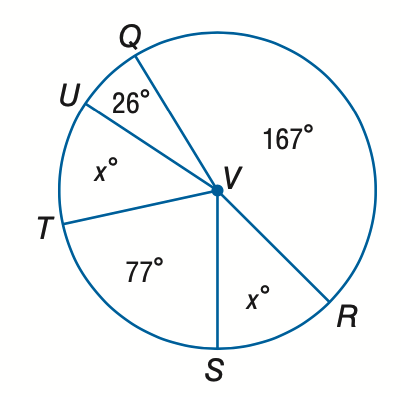Answer the mathemtical geometry problem and directly provide the correct option letter.
Question: Find the value of x.
Choices: A: 22.5 B: 45 C: 60 D: 90 B 